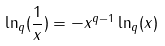Convert formula to latex. <formula><loc_0><loc_0><loc_500><loc_500>\ln _ { q } ( \frac { 1 } { x } ) = - x ^ { q - 1 } \ln _ { q } ( x )</formula> 